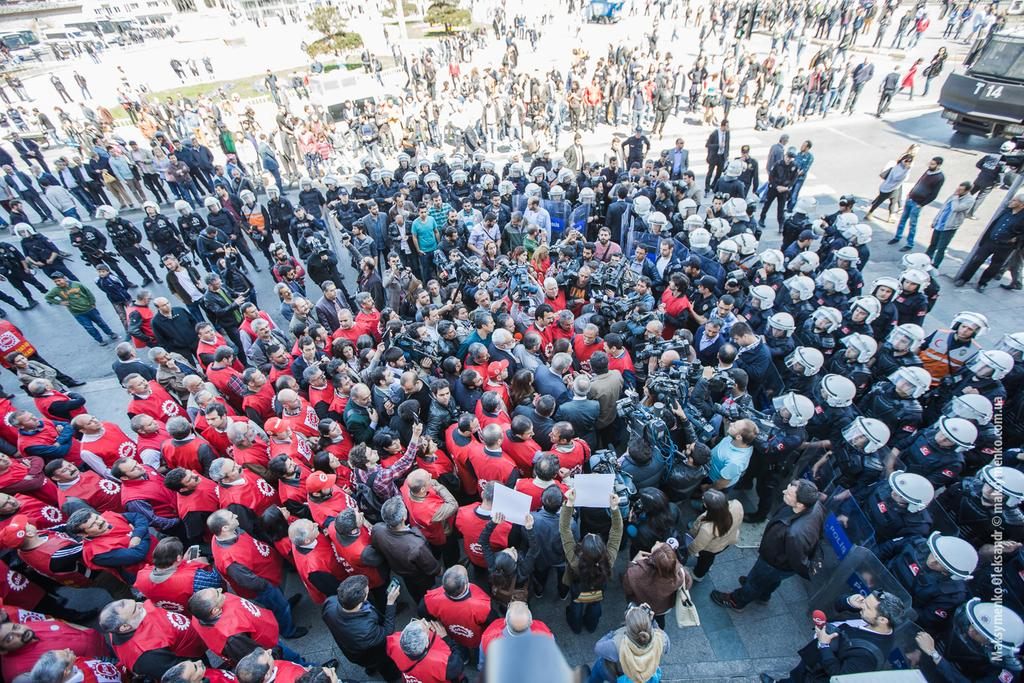What is happening in the middle of the image? There are many people gathered in the middle of the image. Can you describe the people at the back of the image? There are policemen standing at the back of the image. What type of root can be seen growing in the image? There is no root visible in the image. What is the wish of the person in the image? The image does not provide any information about the wishes of the people present. 